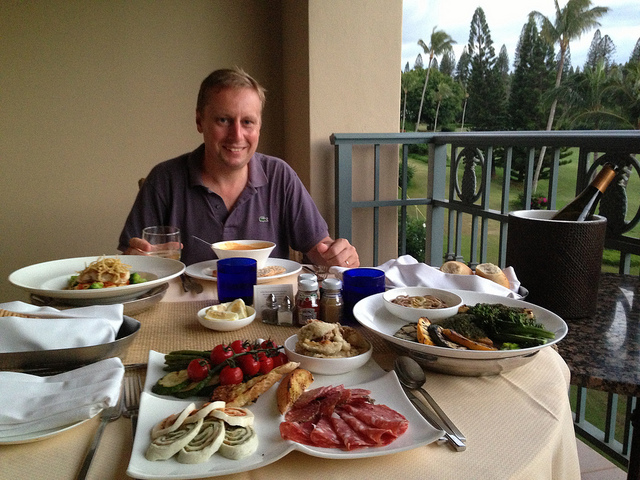Describe the setting in which the person is having their meal. The individual is dining al fresco on a balcony with a cloth-covered table, overlooking a picturesque view of what appears to be a tropical landscape with palm trees. The time of day suggests early evening, as evidenced by the soft ambient light and the presence of outdoor lanterns, possibly following a sunset. Is this setting suitable for a romantic dinner? Absolutely, the intimate table setting, combined with the tranquil outdoors and the privacy offered by the balcony, makes it an ideal spot for a romantic dinner for two. 